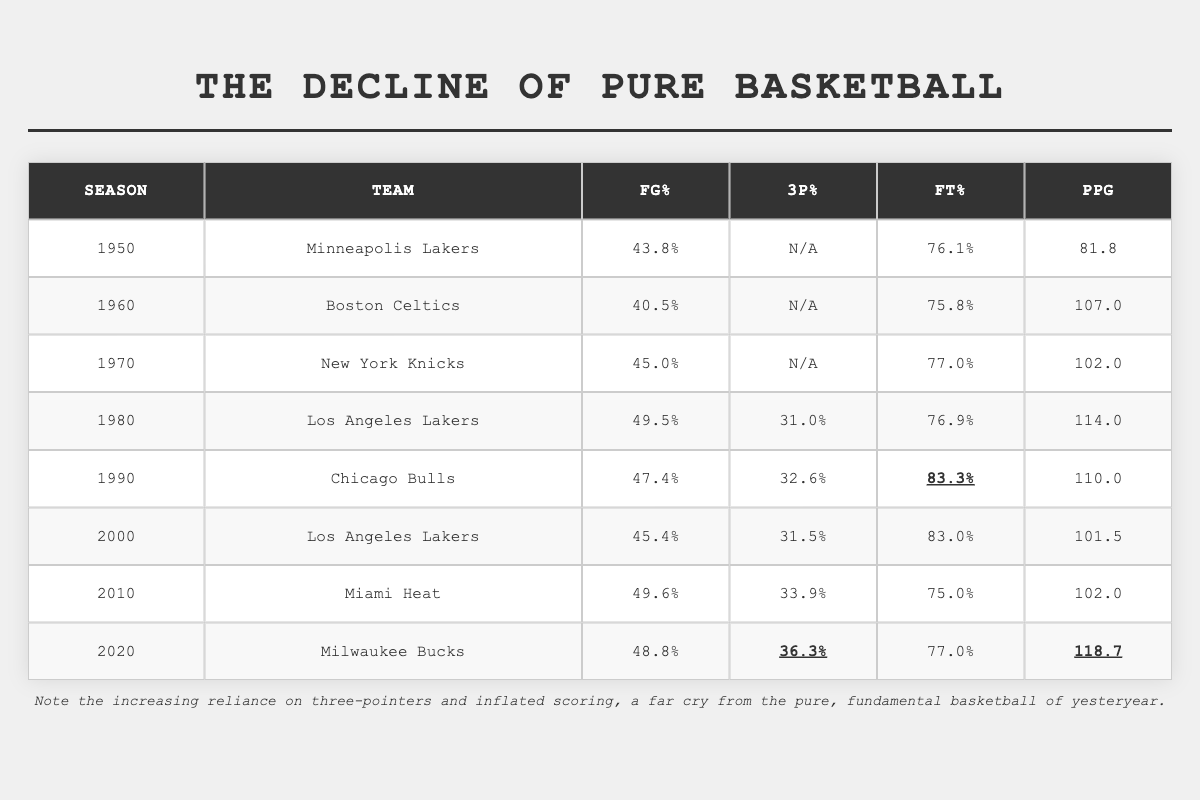What was the highest Field Goal Percentage recorded in the table? In the table, we look for the maximum value in the Field Goal Percentage column. The highest value is 49.6% from the Miami Heat in the 2010 season.
Answer: 49.6% Did any team have a Free Throw Percentage above 80%? By examining the Free Throw Percentage column, we see that the Chicago Bulls in 1990 had a Free Throw Percentage of 83.3%, which is above 80%.
Answer: Yes What is the difference in Points Per Game between the 1980 Los Angeles Lakers and the 2020 Milwaukee Bucks? For the 1980 Los Angeles Lakers, the Points Per Game is 114.0, and for the 2020 Milwaukee Bucks, it is 118.7. We find the difference: 118.7 - 114.0 = 4.7.
Answer: 4.7 What was the average Field Goal Percentage for the teams listed in the table? We sum up all the Field Goal Percentages: 43.8 + 40.5 + 45.0 + 49.5 + 47.4 + 45.4 + 49.6 + 48.8 = 410.0. There are 8 data points, so we divide by 8: 410.0 / 8 = 51.25.
Answer: 51.25 Which team had the lowest Points Per Game, and what was that value? Looking through the Points Per Game column, we find that the Minneapolis Lakers had the lowest value at 81.8.
Answer: Minneapolis Lakers, 81.8 What is the trend in Free Throw Percentage from the 1950s to the 2020s? We examine the Free Throw Percentages over the decades: 76.1 (1950), 75.8 (1960), 77.0 (1970), 76.9 (1980), 83.3 (1990), 83.0 (2000), 75.0 (2010), 77.0 (2020). The trend is not consistently increasing or decreasing, with fluctuations but an eventual rise in 1990, followed by a decline again.
Answer: Fluctuating trend What percentage of teams recorded a Three Point Percentage above 30%? Only the teams from the 1980s onwards reported Three Point Percentages, specifically the Los Angeles Lakers (31.0), Chicago Bulls (32.6), Miami Heat (33.9), and Milwaukee Bucks (36.3). There are 4 out of 8 teams that have this measurement, which gives us a percentage of (4/8)*100 = 50%.
Answer: 50% What is the total combined Free Throw Percentage of all teams listed? Summing the Free Throw Percentages: 76.1 + 75.8 + 77.0 + 76.9 + 83.3 + 83.0 + 75.0 + 77.0 = 624.1.
Answer: 624.1 Did the 2000 Los Angeles Lakers have a higher Points Per Game than the 2010 Miami Heat? The 2000 Los Angeles Lakers had a Points Per Game of 101.5, while the 2010 Miami Heat had 102.0. Thus, 101.5 is less than 102.0.
Answer: No Which season had the highest Three Point Percentage, and what was that percentage? The highest Three Point Percentage recorded is 36.3% by the Milwaukee Bucks in the 2020 season.
Answer: 2020, 36.3% 